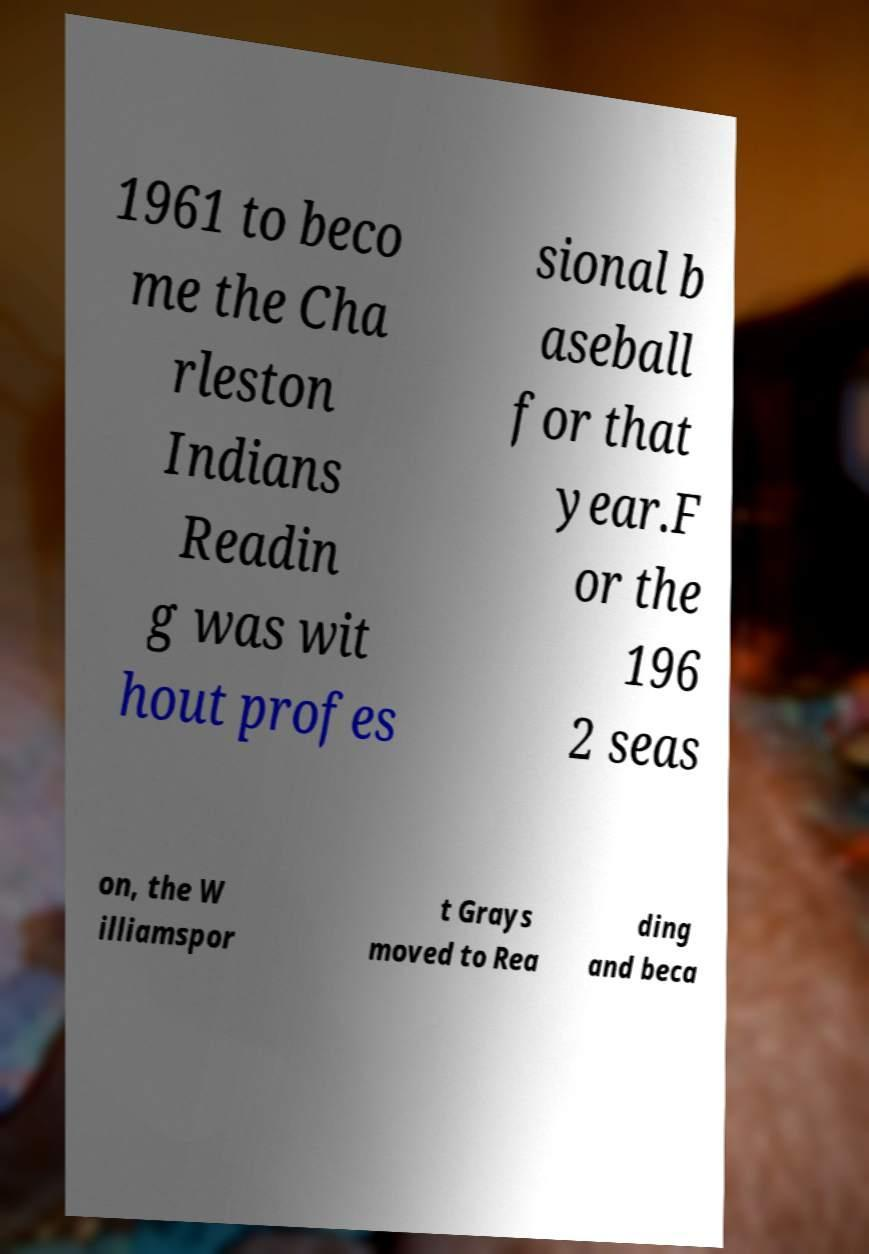Please identify and transcribe the text found in this image. 1961 to beco me the Cha rleston Indians Readin g was wit hout profes sional b aseball for that year.F or the 196 2 seas on, the W illiamspor t Grays moved to Rea ding and beca 